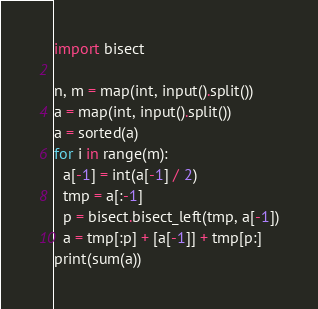Convert code to text. <code><loc_0><loc_0><loc_500><loc_500><_Python_>import bisect

n, m = map(int, input().split())
a = map(int, input().split())
a = sorted(a)
for i in range(m):
  a[-1] = int(a[-1] / 2)
  tmp = a[:-1]
  p = bisect.bisect_left(tmp, a[-1])
  a = tmp[:p] + [a[-1]] + tmp[p:]
print(sum(a))</code> 